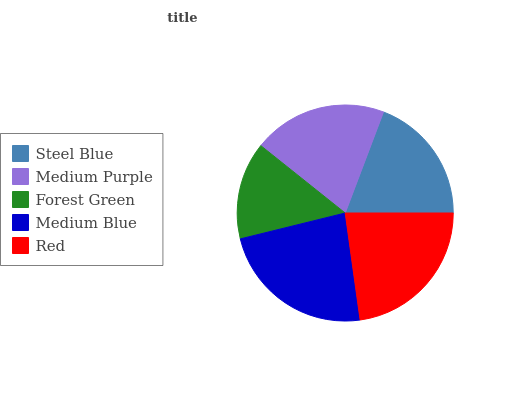Is Forest Green the minimum?
Answer yes or no. Yes. Is Medium Blue the maximum?
Answer yes or no. Yes. Is Medium Purple the minimum?
Answer yes or no. No. Is Medium Purple the maximum?
Answer yes or no. No. Is Medium Purple greater than Steel Blue?
Answer yes or no. Yes. Is Steel Blue less than Medium Purple?
Answer yes or no. Yes. Is Steel Blue greater than Medium Purple?
Answer yes or no. No. Is Medium Purple less than Steel Blue?
Answer yes or no. No. Is Medium Purple the high median?
Answer yes or no. Yes. Is Medium Purple the low median?
Answer yes or no. Yes. Is Steel Blue the high median?
Answer yes or no. No. Is Forest Green the low median?
Answer yes or no. No. 